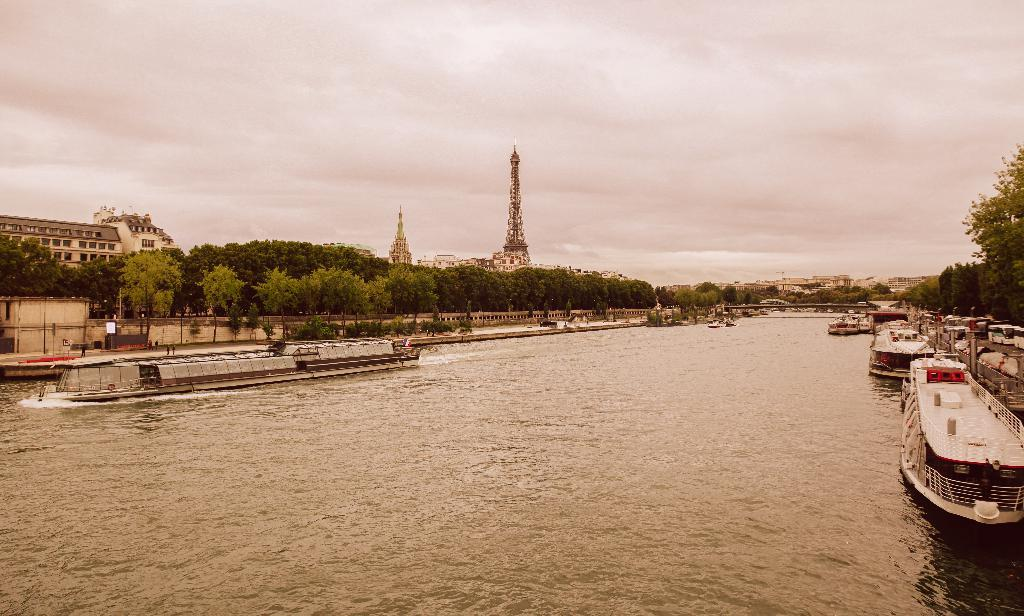What is positioned above the water in the image? There are boats above the water in the image. What can be seen in the distance beyond the water? Trees and buildings are visible in the distance. What structure is present in the image? There is a tower in the image. How would you describe the sky in the image? The sky is cloudy in the image. Are there any yams growing near the tower in the image? There is no mention of yams in the image, and they are not visible in the provided facts. Can you see any fairies flying around the boats in the image? There is no mention of fairies in the image, and they are not visible in the provided facts. 